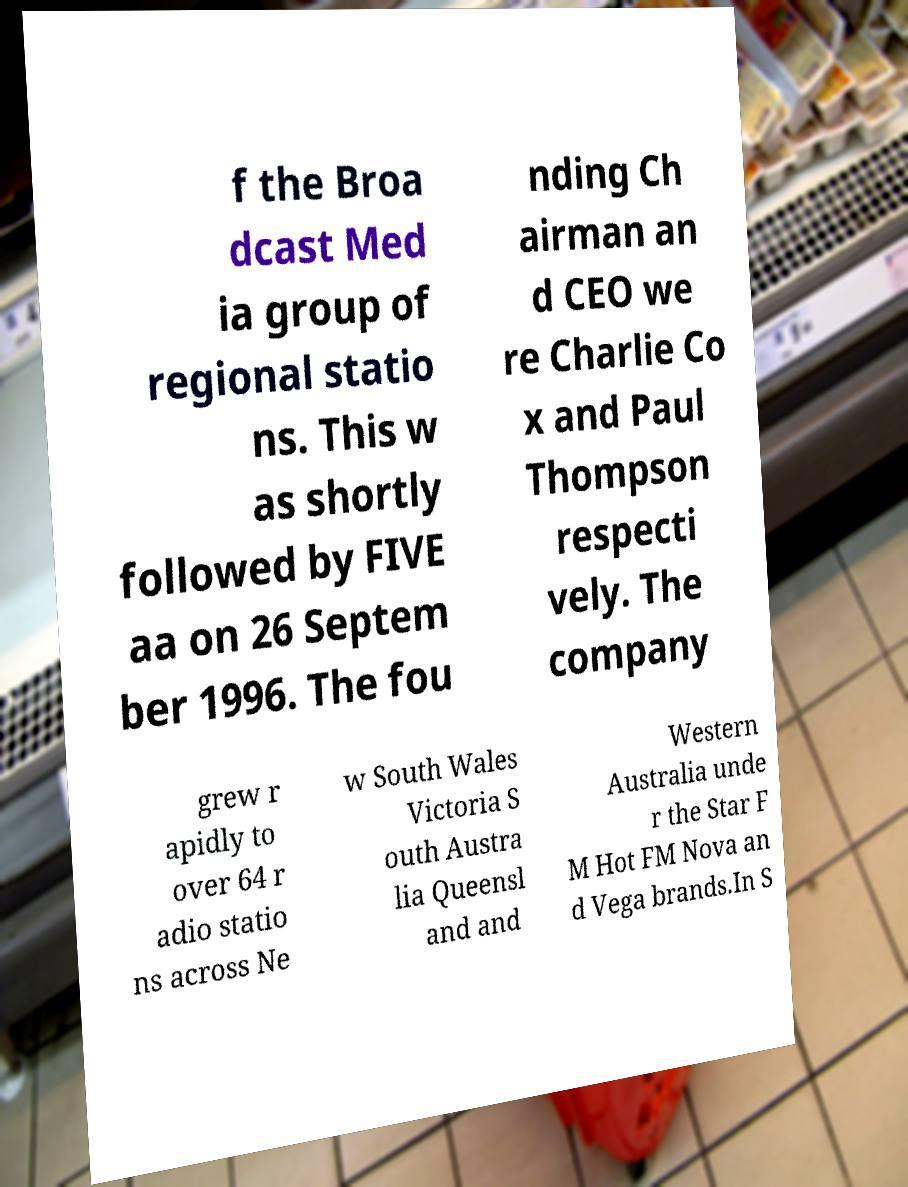Could you extract and type out the text from this image? f the Broa dcast Med ia group of regional statio ns. This w as shortly followed by FIVE aa on 26 Septem ber 1996. The fou nding Ch airman an d CEO we re Charlie Co x and Paul Thompson respecti vely. The company grew r apidly to over 64 r adio statio ns across Ne w South Wales Victoria S outh Austra lia Queensl and and Western Australia unde r the Star F M Hot FM Nova an d Vega brands.In S 